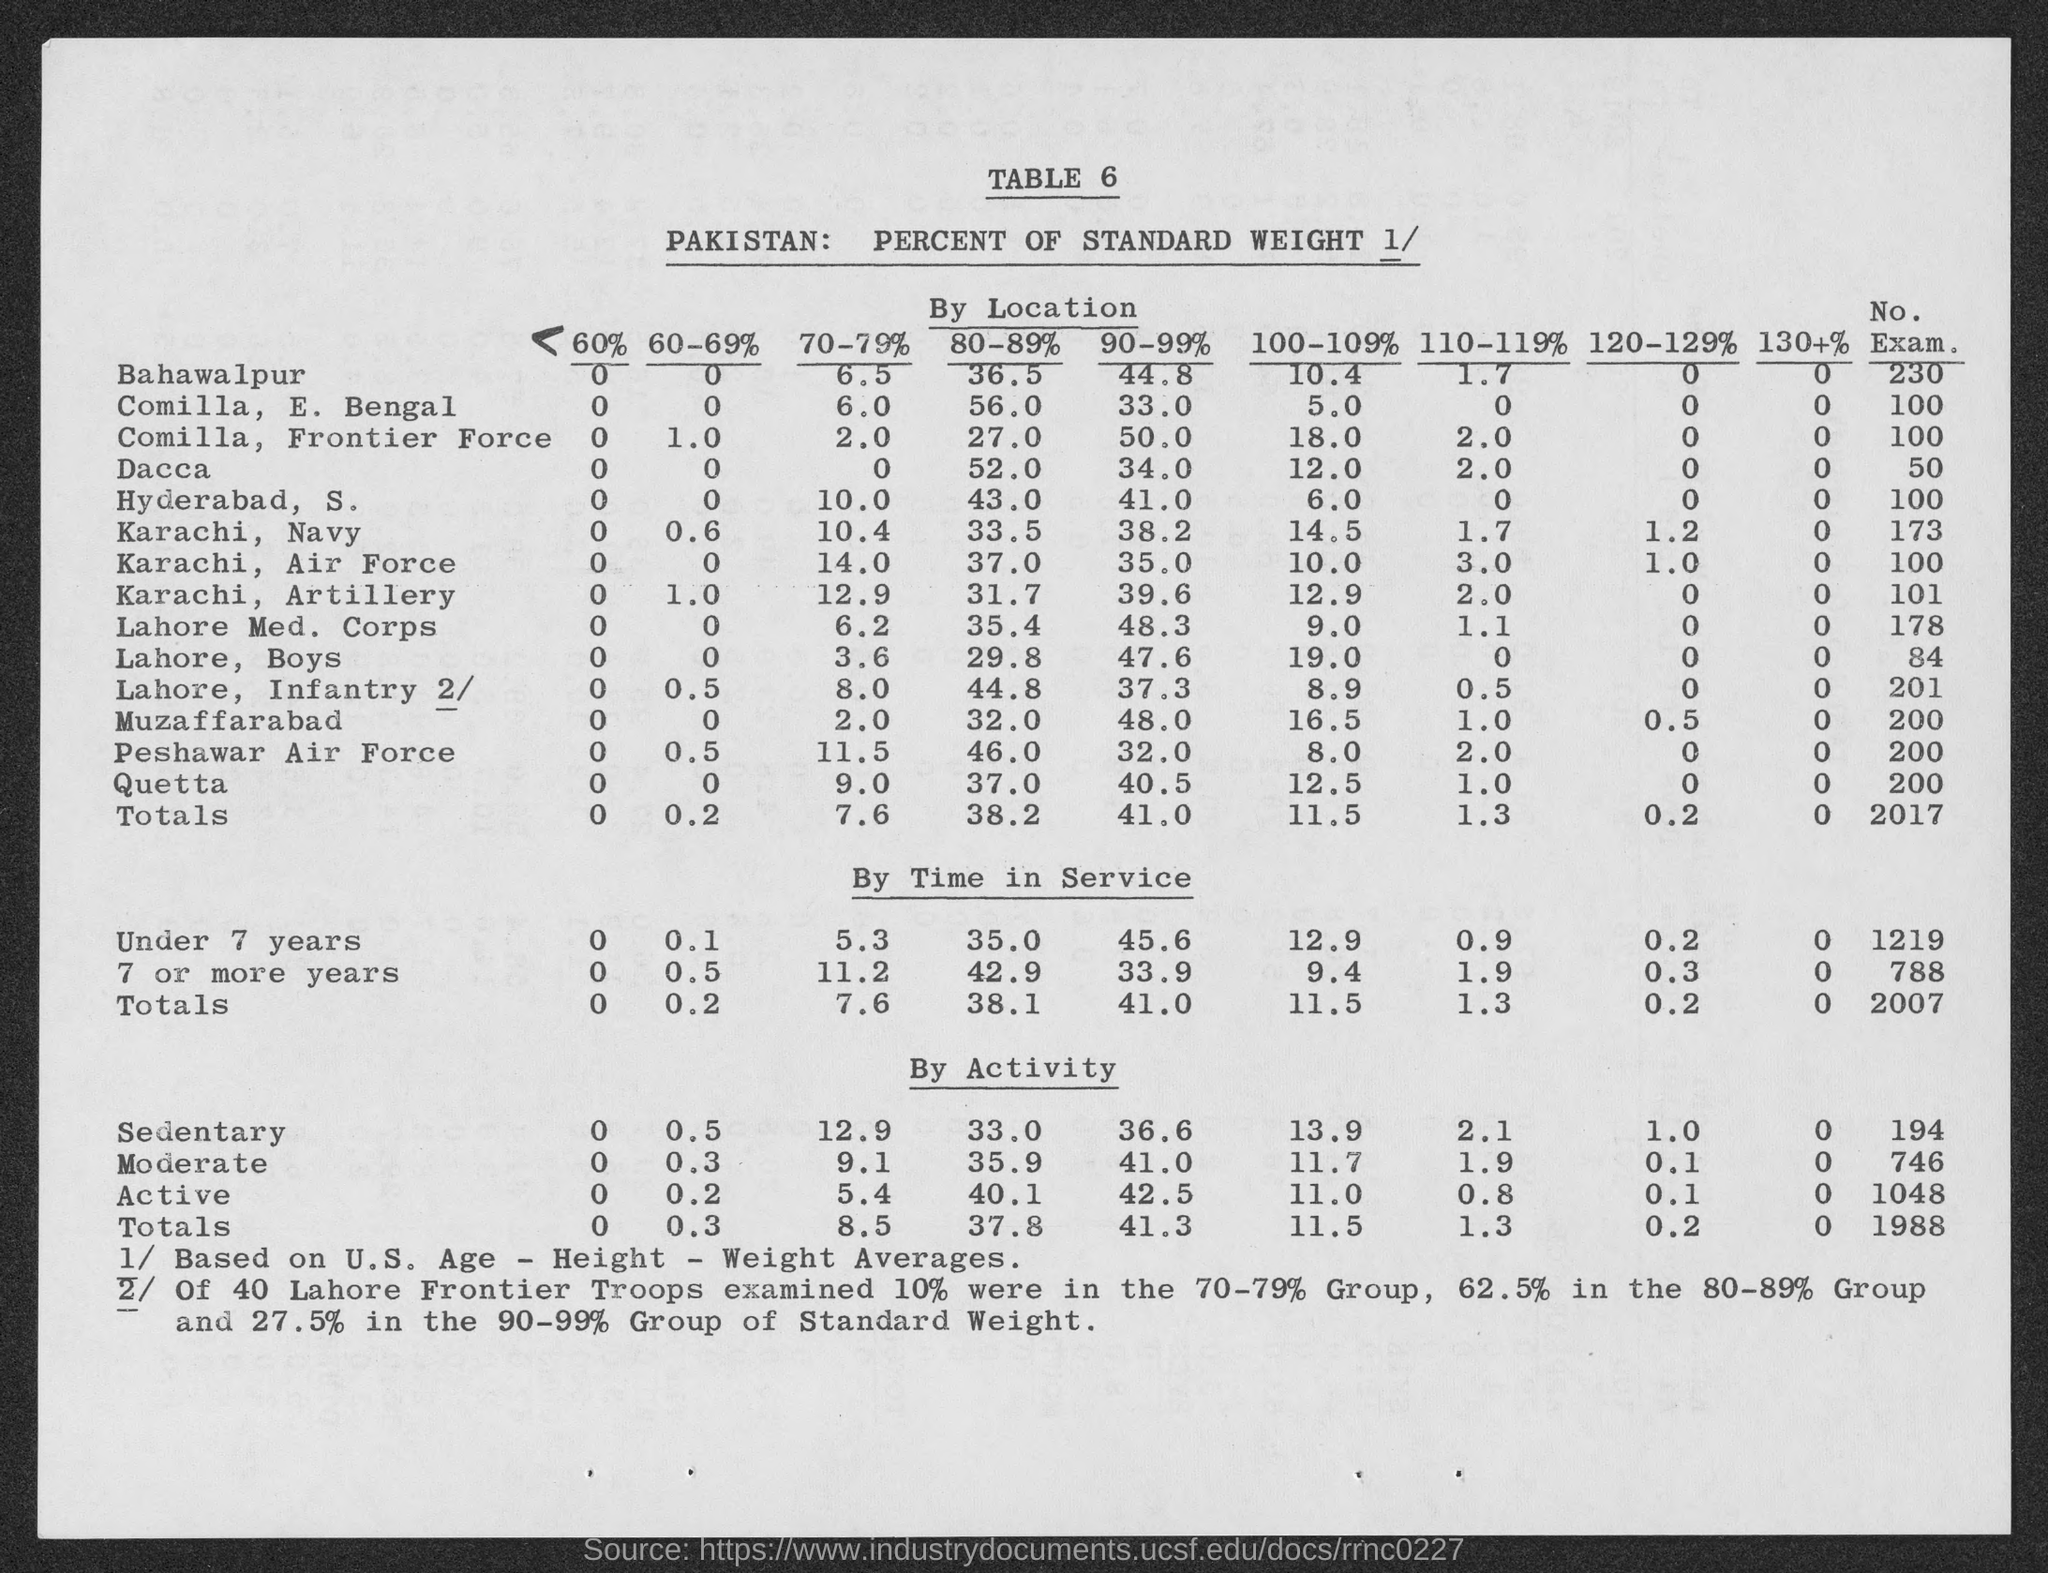What are the totals for 60%?
Give a very brief answer. 0. What are the totals for 60-69% in "By Location" ?
Offer a very short reply. 0.2. What are the totals for 70-79%  in "By Location" ?
Your answer should be very brief. 7.6. What are the totals for 80-89% in "By Location" ?
Provide a succinct answer. 38.2. What are the totals for 90-99% in "By Location" ?
Make the answer very short. 41.0. What are the totals for 100-109%?
Your response must be concise. 11.5. What are the totals for 110-119%?
Your answer should be very brief. 1.3. What are the totals for 120-129%?
Keep it short and to the point. 0.2. What are the totals for 130+%?
Offer a very short reply. 0. What are the totals for No. Exam. in "By Location" ?
Keep it short and to the point. 2017. 